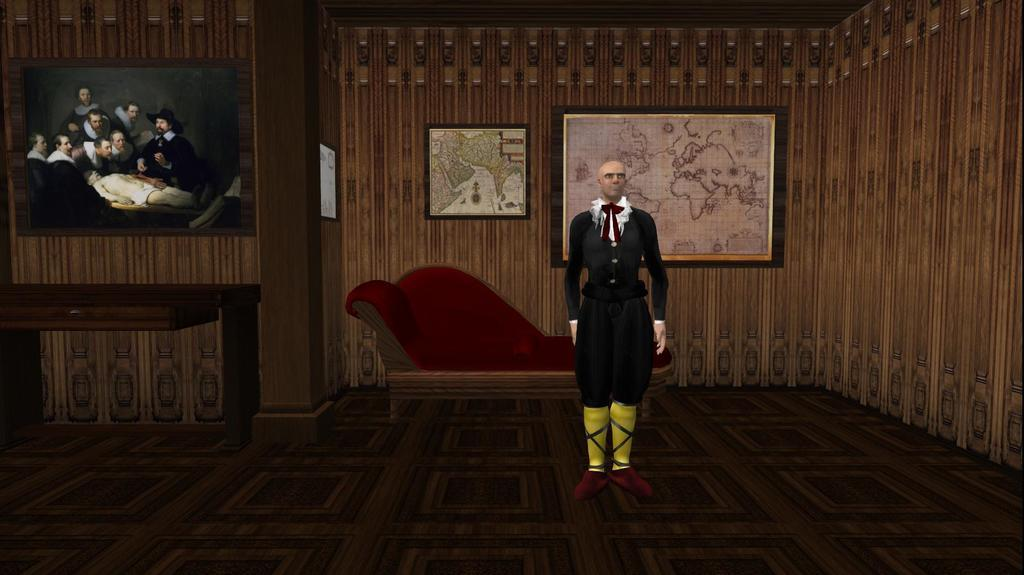What is the main subject in the foreground of the image? There is a man standing in the foreground of the image. What is the man standing on? The man is standing on the floor. What can be seen on the wall in the background of the image? There are frames on the wall in the background of the image. What furniture is visible in the background of the image? There is a couch and a table in the background of the image. What type of muscle is being flexed by the man in the image? There is no indication in the image that the man is flexing any muscles, so it cannot be determined from the picture. 